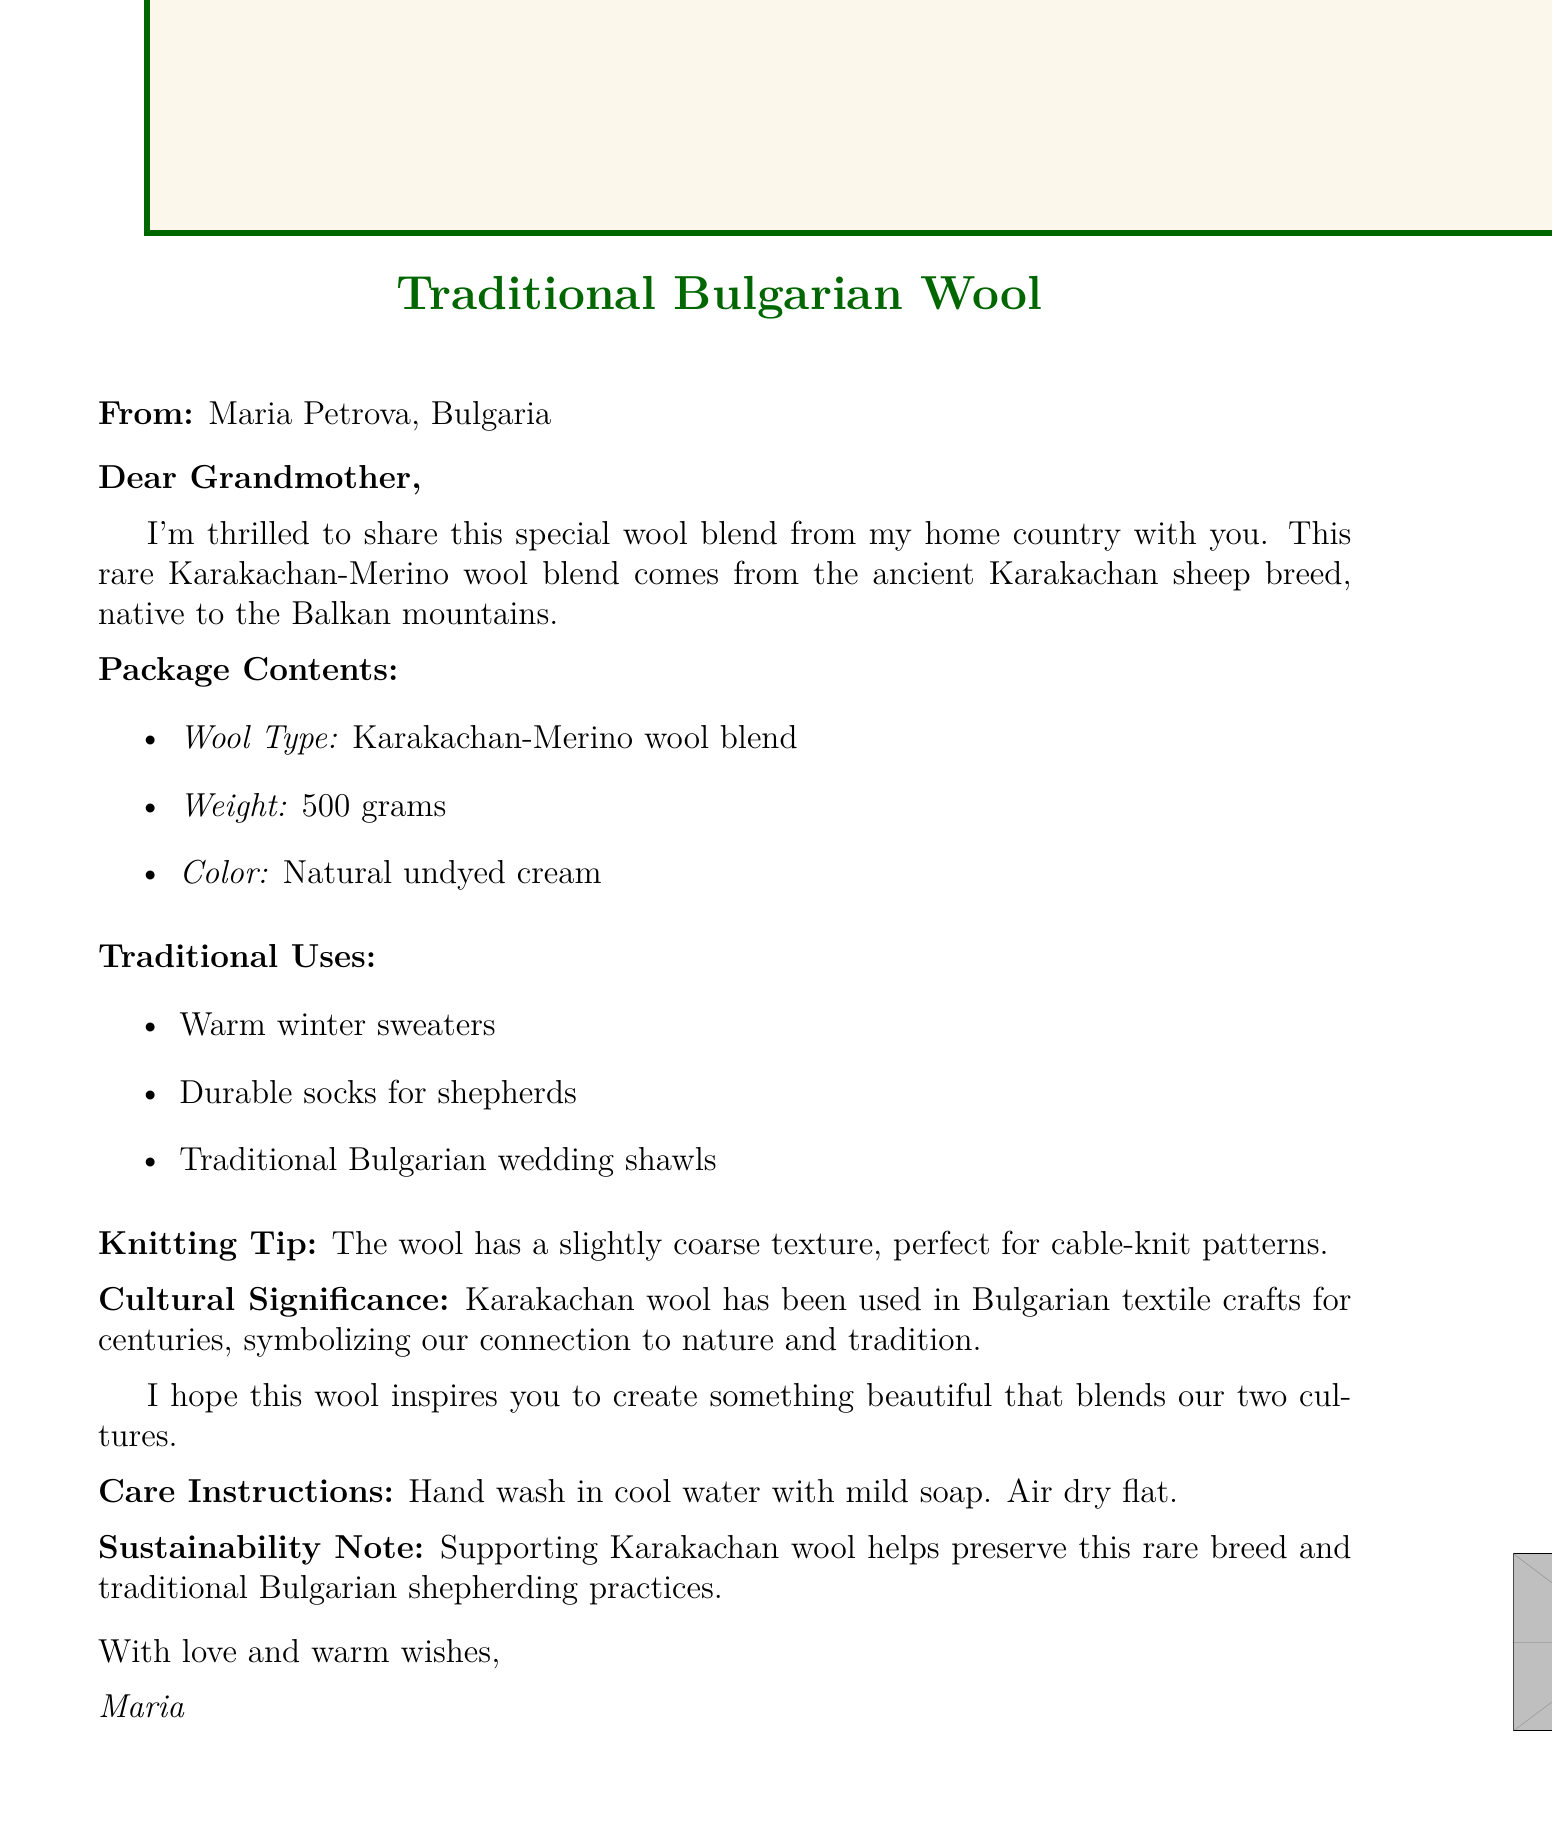What is the sender's name? The sender's name is provided in the document and is Maria Petrova.
Answer: Maria Petrova What is the wool blend made from? The document describes the wool blend as Karakachan-Merino, listing the specific sheep breed it comes from.
Answer: Karakachan-Merino How much does the wool blend weigh? The weight of the wool blend is a specific measurement included in the document.
Answer: 500 grams What color is the wool blend? The document specifies the color of the wool blend as a particular shade.
Answer: Natural undyed cream What traditional use is mentioned first? The document lists various traditional uses, with the first one being an item made from the wool blend.
Answer: Warm winter sweaters What knitting technique is suggested in the note? The document contains a knitting tip that recommends using a specific technique with the wool.
Answer: Cable-knit patterns What is the care instruction for the wool? The document includes a specific instruction regarding the care of the wool blend.
Answer: Hand wash in cool water with mild soap What is the sustainability note mentioned in the document? The document includes information emphasizing sustainability related to the wool blend.
Answer: Supporting Karakachan wool helps preserve this rare breed What does the sender hope the wool inspires? The sender expresses a wish for what the recipient will create with the wool blend.
Answer: Something beautiful that blends our two cultures 